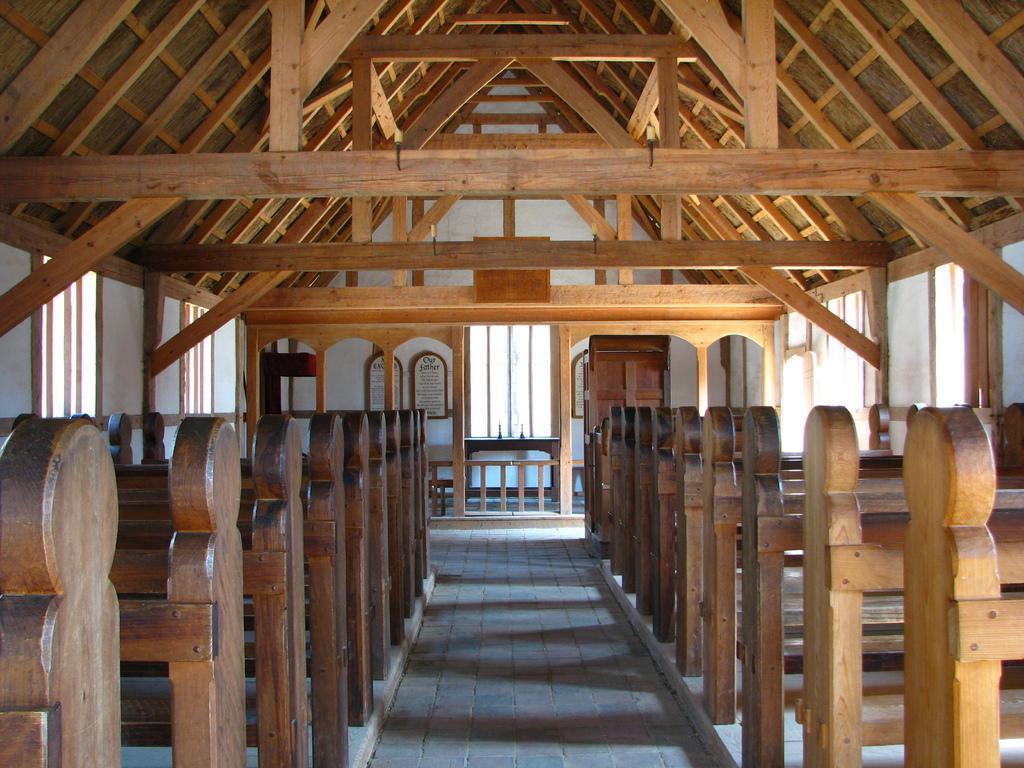Can you describe this image briefly? In this image i can see wooden benches on the floor and there are many windows. 